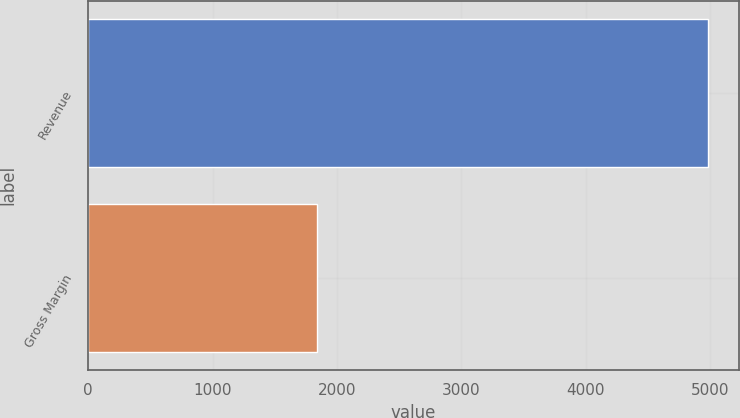Convert chart. <chart><loc_0><loc_0><loc_500><loc_500><bar_chart><fcel>Revenue<fcel>Gross Margin<nl><fcel>4982<fcel>1840<nl></chart> 